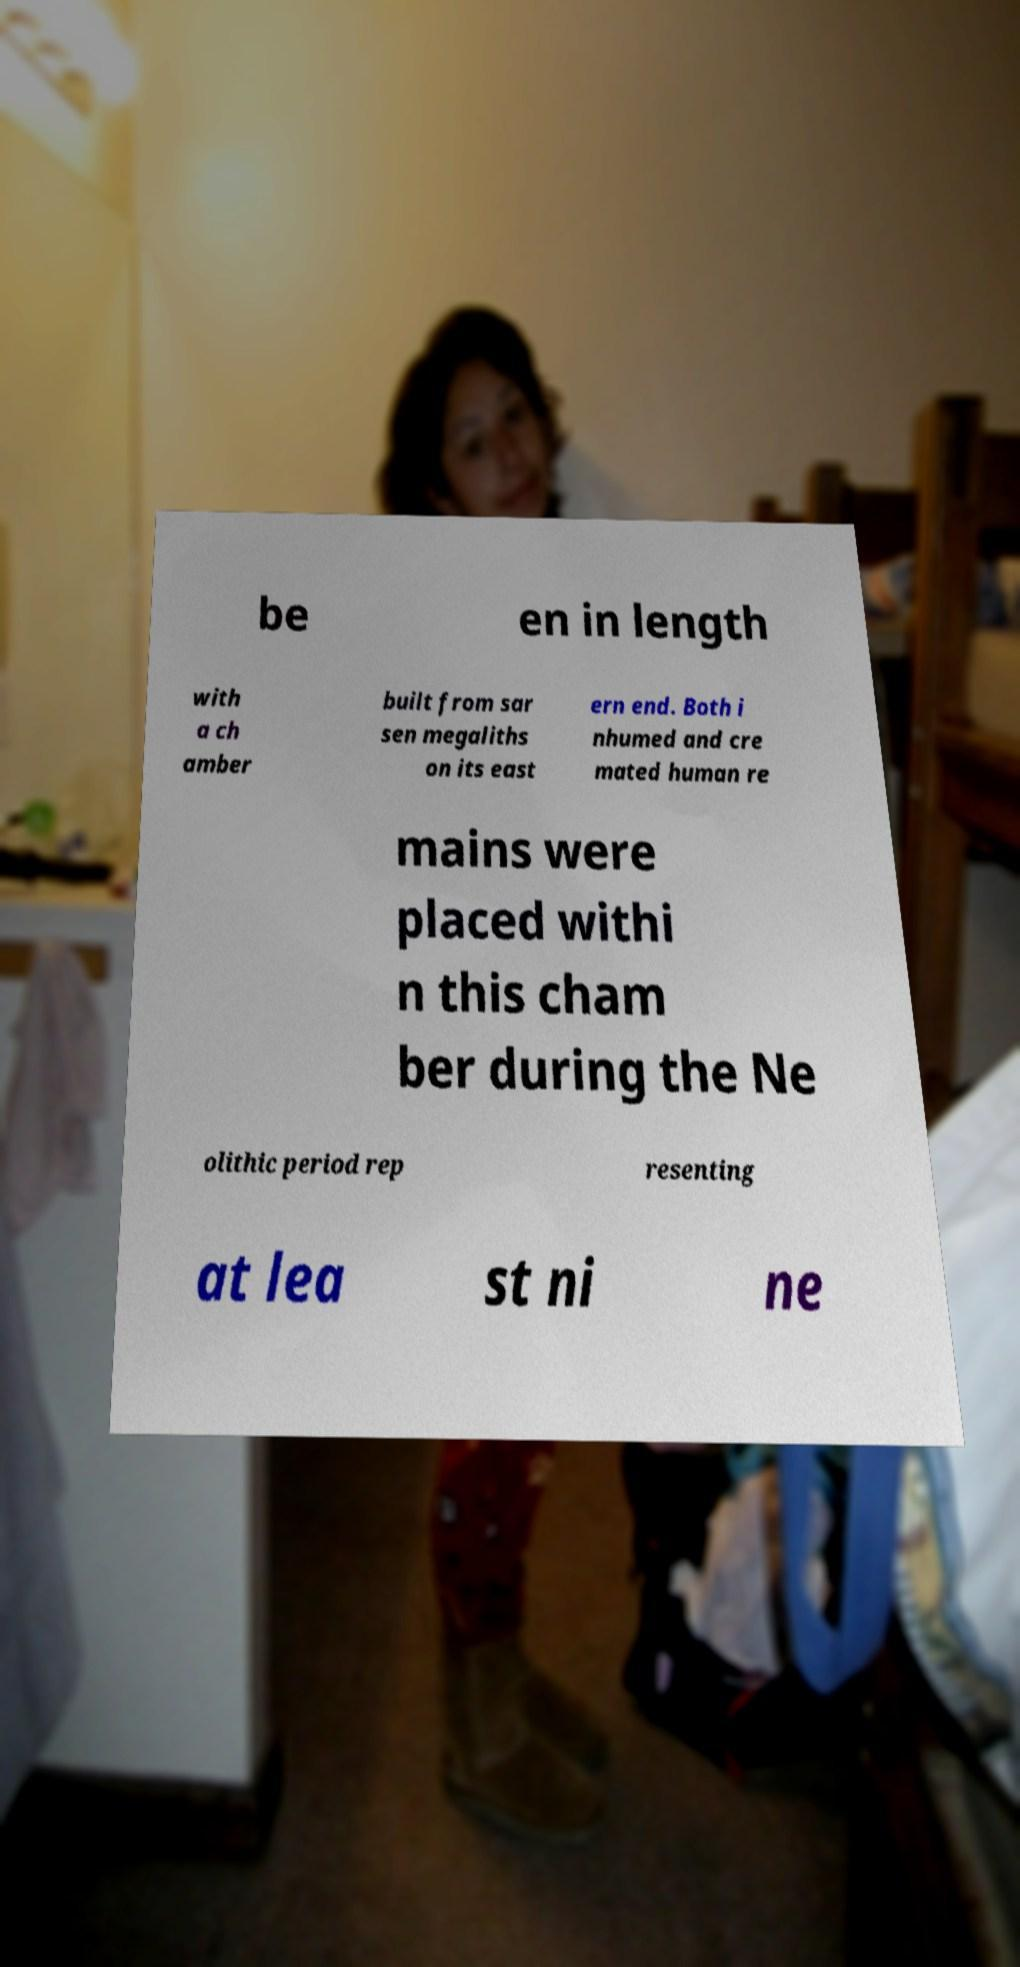Can you accurately transcribe the text from the provided image for me? be en in length with a ch amber built from sar sen megaliths on its east ern end. Both i nhumed and cre mated human re mains were placed withi n this cham ber during the Ne olithic period rep resenting at lea st ni ne 